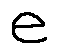<formula> <loc_0><loc_0><loc_500><loc_500>e</formula> 